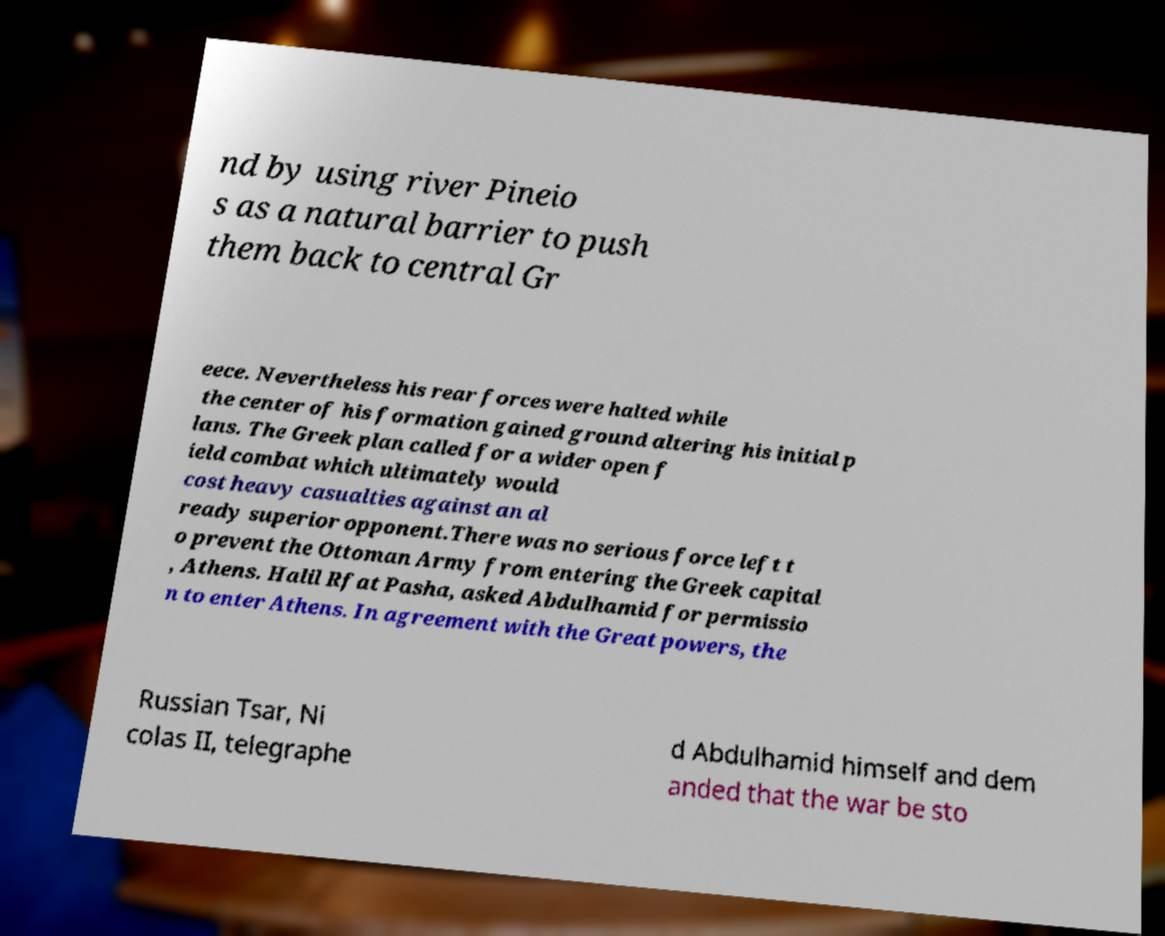Please read and relay the text visible in this image. What does it say? nd by using river Pineio s as a natural barrier to push them back to central Gr eece. Nevertheless his rear forces were halted while the center of his formation gained ground altering his initial p lans. The Greek plan called for a wider open f ield combat which ultimately would cost heavy casualties against an al ready superior opponent.There was no serious force left t o prevent the Ottoman Army from entering the Greek capital , Athens. Halil Rfat Pasha, asked Abdulhamid for permissio n to enter Athens. In agreement with the Great powers, the Russian Tsar, Ni colas II, telegraphe d Abdulhamid himself and dem anded that the war be sto 